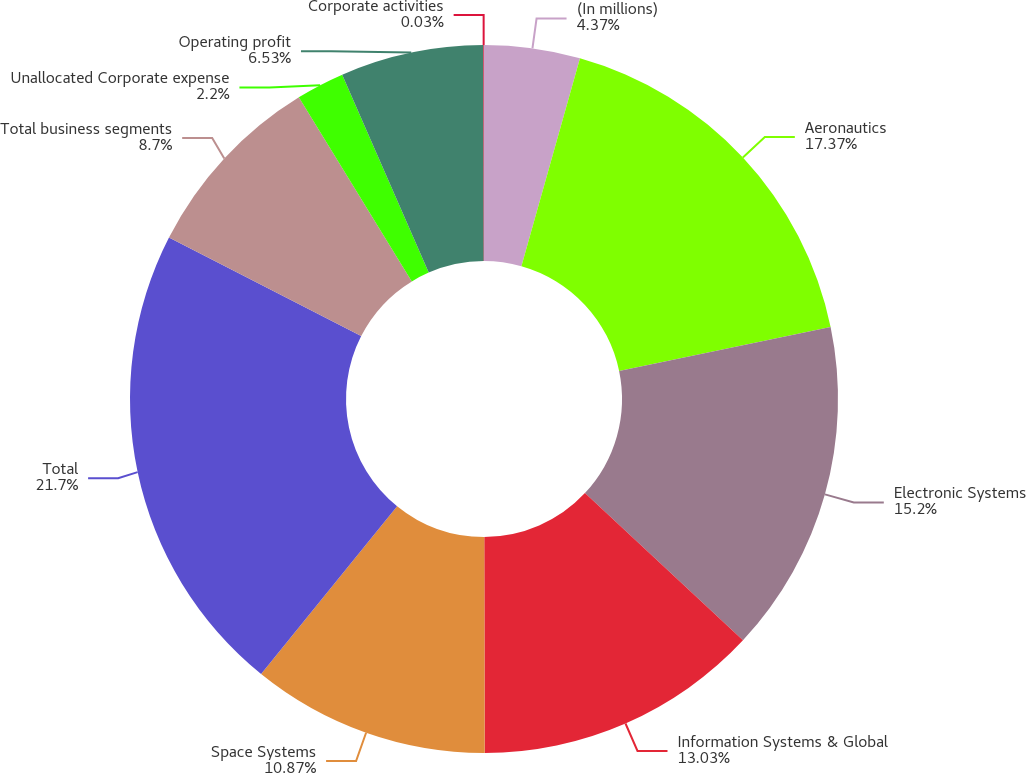<chart> <loc_0><loc_0><loc_500><loc_500><pie_chart><fcel>(In millions)<fcel>Aeronautics<fcel>Electronic Systems<fcel>Information Systems & Global<fcel>Space Systems<fcel>Total<fcel>Total business segments<fcel>Unallocated Corporate expense<fcel>Operating profit<fcel>Corporate activities<nl><fcel>4.37%<fcel>17.37%<fcel>15.2%<fcel>13.03%<fcel>10.87%<fcel>21.7%<fcel>8.7%<fcel>2.2%<fcel>6.53%<fcel>0.03%<nl></chart> 